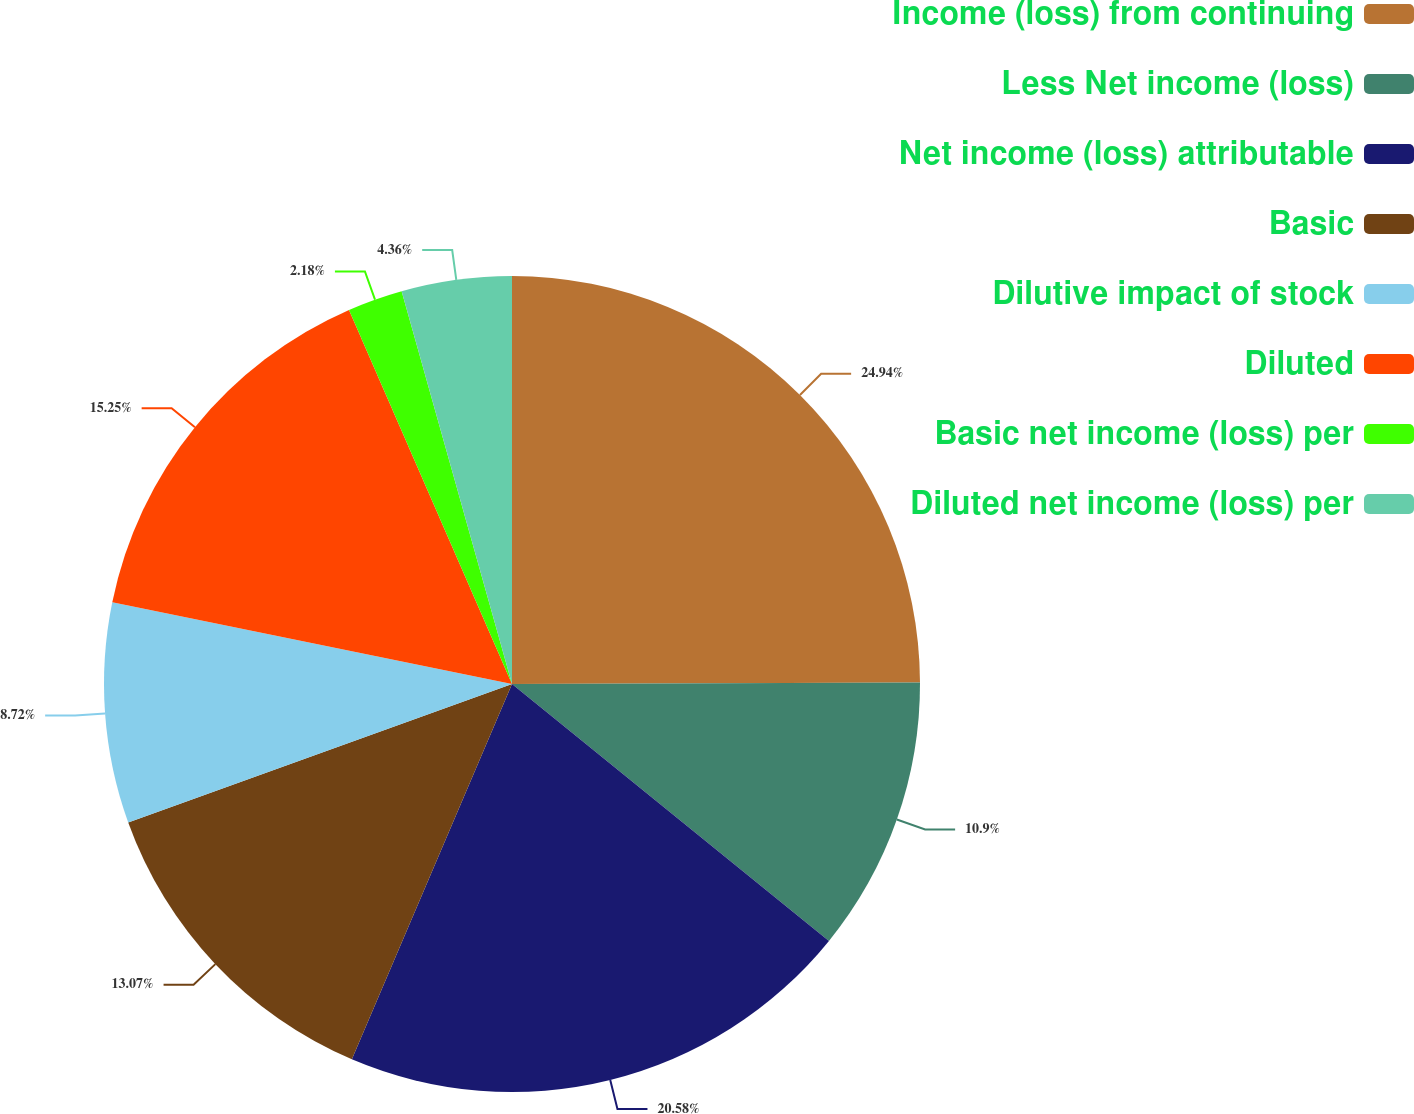Convert chart to OTSL. <chart><loc_0><loc_0><loc_500><loc_500><pie_chart><fcel>Income (loss) from continuing<fcel>Less Net income (loss)<fcel>Net income (loss) attributable<fcel>Basic<fcel>Dilutive impact of stock<fcel>Diluted<fcel>Basic net income (loss) per<fcel>Diluted net income (loss) per<nl><fcel>24.94%<fcel>10.9%<fcel>20.58%<fcel>13.07%<fcel>8.72%<fcel>15.25%<fcel>2.18%<fcel>4.36%<nl></chart> 